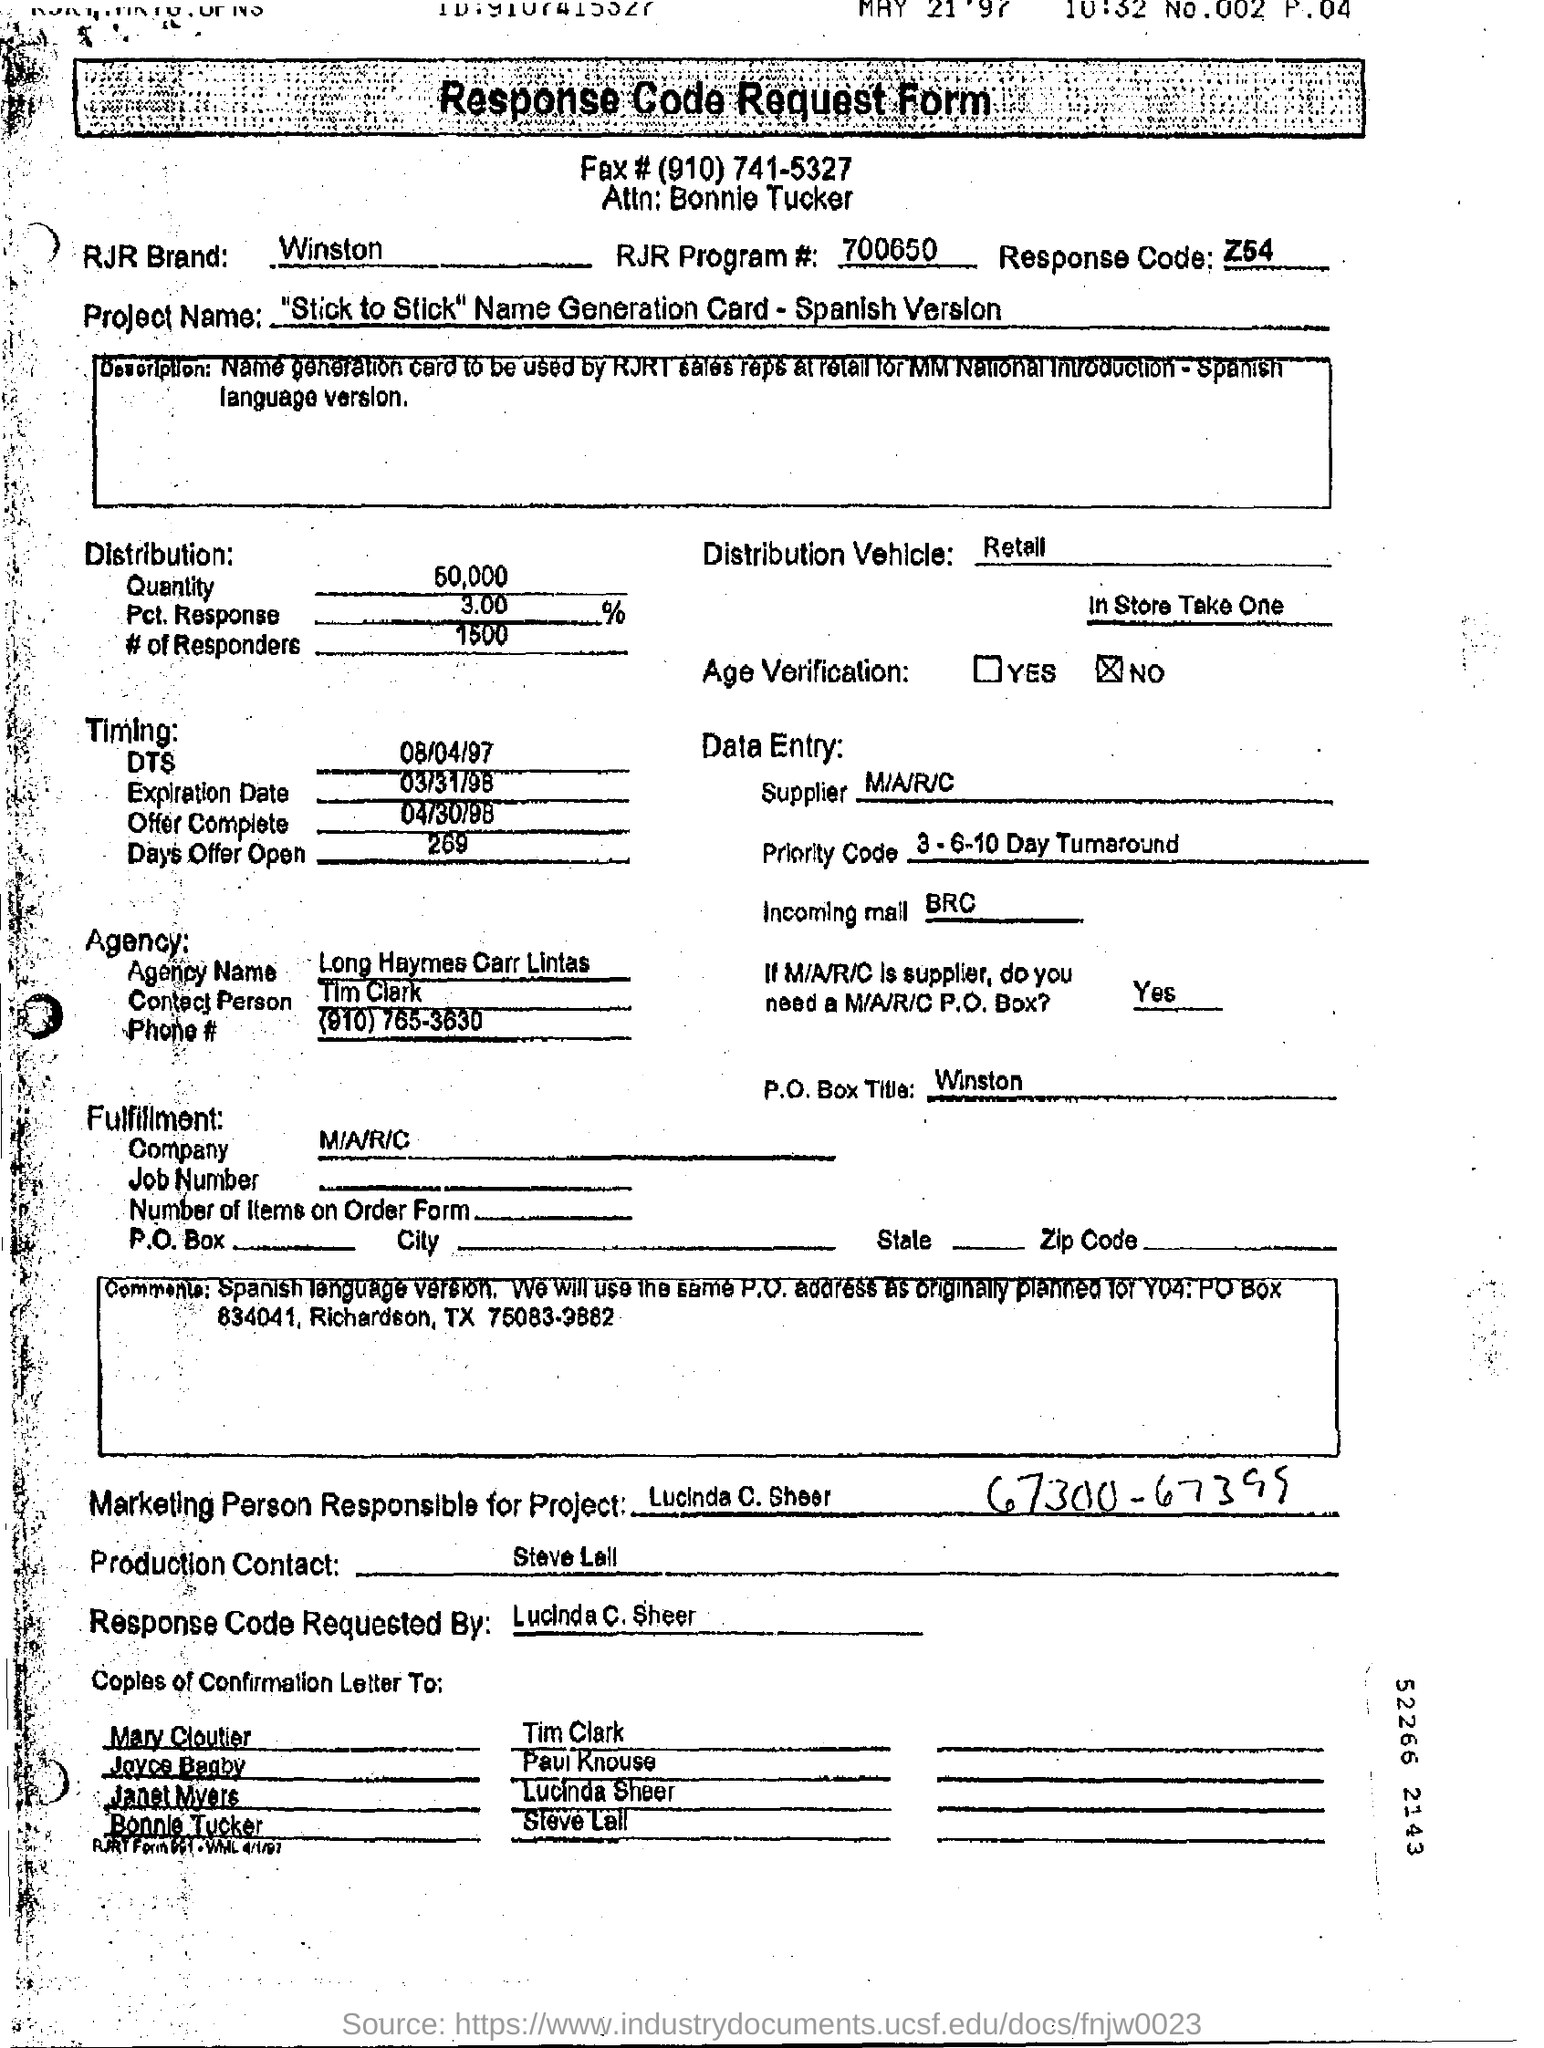Give some essential details in this illustration. The quantity of distribution is approximately 50,000. Please provide the RJR Program Number for this form, which is 700650... The person responsible for this project is Lucinda C. Sheer. The RJR brand name in the form of "Winston" is a well-known cigarette product. The assigned response code is Z54... 